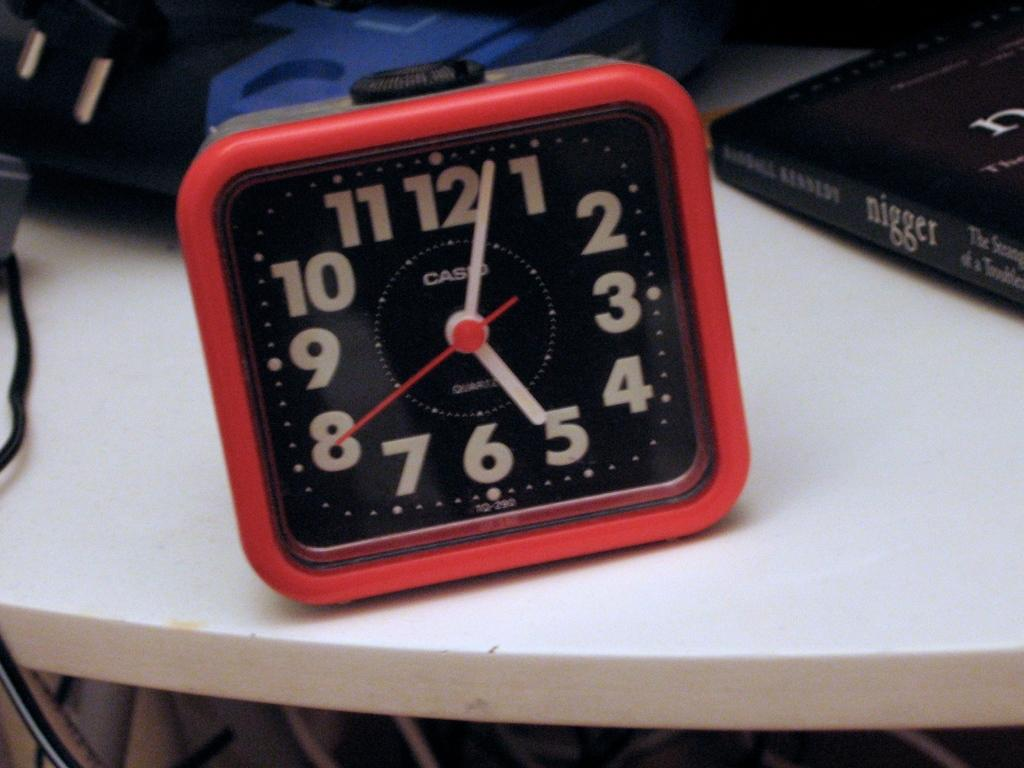<image>
Present a compact description of the photo's key features. A red clock shows the word "casio" on the face. 